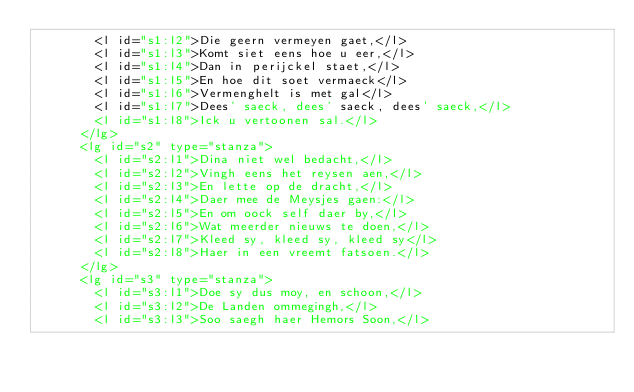Convert code to text. <code><loc_0><loc_0><loc_500><loc_500><_XML_>        <l id="s1:l2">Die geern vermeyen gaet,</l>
        <l id="s1:l3">Komt siet eens hoe u eer,</l>
        <l id="s1:l4">Dan in perijckel staet,</l>
        <l id="s1:l5">En hoe dit soet vermaeck</l>
        <l id="s1:l6">Vermenghelt is met gal</l>
        <l id="s1:l7">Dees' saeck, dees' saeck, dees' saeck,</l>
        <l id="s1:l8">Ick u vertoonen sal.</l>
      </lg>
      <lg id="s2" type="stanza">
        <l id="s2:l1">Dina niet wel bedacht,</l>
        <l id="s2:l2">Vingh eens het reysen aen,</l>
        <l id="s2:l3">En lette op de dracht,</l>
        <l id="s2:l4">Daer mee de Meysjes gaen:</l>
        <l id="s2:l5">En om oock self daer by,</l>
        <l id="s2:l6">Wat meerder nieuws te doen,</l>
        <l id="s2:l7">Kleed sy, kleed sy, kleed sy</l>
        <l id="s2:l8">Haer in een vreemt fatsoen.</l>
      </lg>
      <lg id="s3" type="stanza">
        <l id="s3:l1">Doe sy dus moy, en schoon,</l>
        <l id="s3:l2">De Landen ommegingh,</l>
        <l id="s3:l3">Soo saegh haer Hemors Soon,</l></code> 